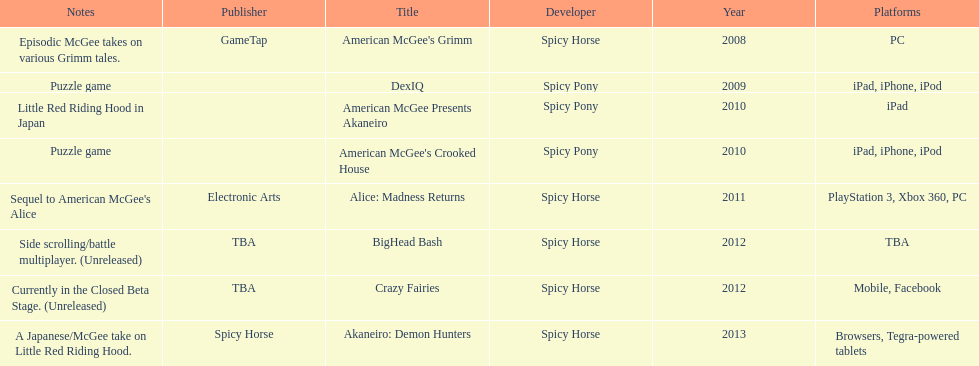Spicy pony released a total of three games; their game, "american mcgee's crooked house" was released on which platforms? Ipad, iphone, ipod. 